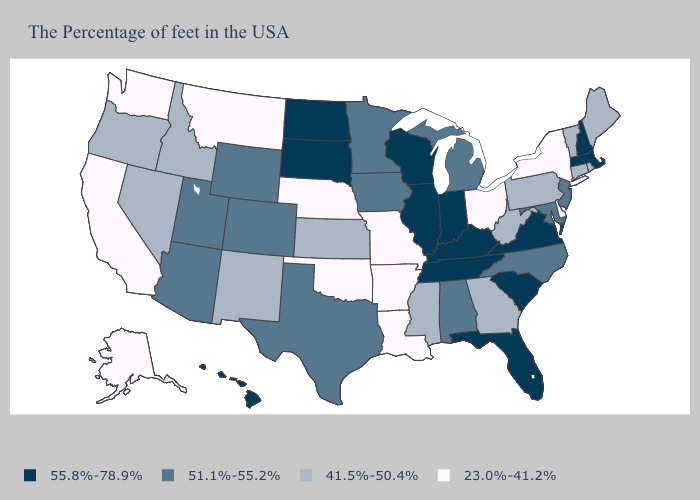Name the states that have a value in the range 55.8%-78.9%?
Keep it brief. Massachusetts, New Hampshire, Virginia, South Carolina, Florida, Kentucky, Indiana, Tennessee, Wisconsin, Illinois, South Dakota, North Dakota, Hawaii. Name the states that have a value in the range 55.8%-78.9%?
Concise answer only. Massachusetts, New Hampshire, Virginia, South Carolina, Florida, Kentucky, Indiana, Tennessee, Wisconsin, Illinois, South Dakota, North Dakota, Hawaii. Among the states that border Wisconsin , which have the highest value?
Answer briefly. Illinois. What is the highest value in the USA?
Keep it brief. 55.8%-78.9%. What is the value of Vermont?
Short answer required. 41.5%-50.4%. What is the value of Idaho?
Short answer required. 41.5%-50.4%. What is the highest value in states that border Arkansas?
Short answer required. 55.8%-78.9%. Does New York have the same value as Illinois?
Write a very short answer. No. What is the value of Minnesota?
Be succinct. 51.1%-55.2%. What is the lowest value in the South?
Keep it brief. 23.0%-41.2%. What is the highest value in the Northeast ?
Write a very short answer. 55.8%-78.9%. What is the lowest value in the USA?
Be succinct. 23.0%-41.2%. Name the states that have a value in the range 55.8%-78.9%?
Be succinct. Massachusetts, New Hampshire, Virginia, South Carolina, Florida, Kentucky, Indiana, Tennessee, Wisconsin, Illinois, South Dakota, North Dakota, Hawaii. Name the states that have a value in the range 23.0%-41.2%?
Keep it brief. New York, Delaware, Ohio, Louisiana, Missouri, Arkansas, Nebraska, Oklahoma, Montana, California, Washington, Alaska. Among the states that border Rhode Island , does Massachusetts have the lowest value?
Quick response, please. No. 